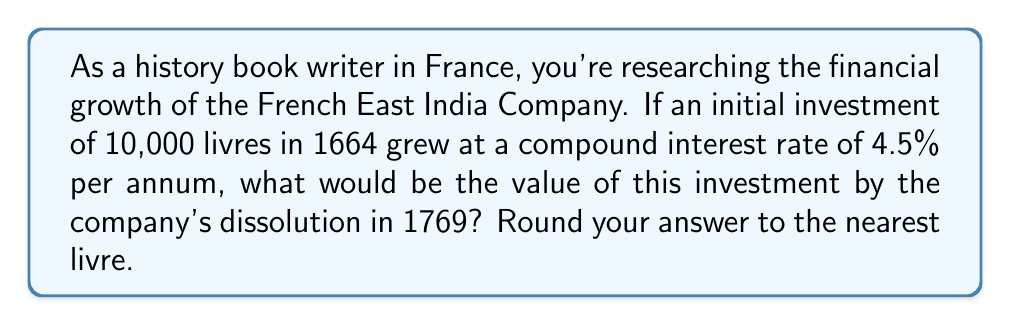Could you help me with this problem? To solve this problem, we'll use the compound interest formula:

$$A = P(1 + r)^t$$

Where:
$A$ = Final amount
$P$ = Principal (initial investment)
$r$ = Annual interest rate (as a decimal)
$t$ = Time in years

Given:
$P = 10,000$ livres
$r = 4.5\% = 0.045$
$t = 1769 - 1664 = 105$ years

Let's substitute these values into the formula:

$$A = 10,000(1 + 0.045)^{105}$$

Now, let's calculate:

$$A = 10,000 \times (1.045)^{105}$$

Using a calculator or computer for this large exponent:

$$A = 10,000 \times 106.2307...$$

$$A = 1,062,307.23...$$

Rounding to the nearest livre:

$$A \approx 1,062,307\text{ livres}$$
Answer: 1,062,307 livres 